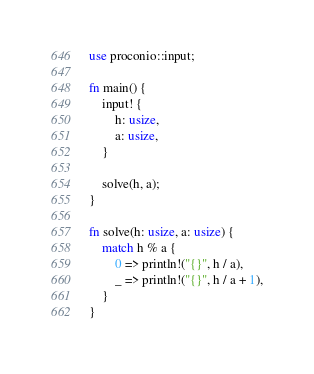Convert code to text. <code><loc_0><loc_0><loc_500><loc_500><_Rust_>use proconio::input;

fn main() {
    input! {
        h: usize,
        a: usize,
    }

    solve(h, a);
}

fn solve(h: usize, a: usize) {
    match h % a {
        0 => println!("{}", h / a),
        _ => println!("{}", h / a + 1),
    }
}
</code> 